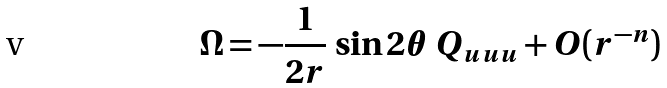<formula> <loc_0><loc_0><loc_500><loc_500>\Omega = - \frac { 1 } { 2 r } \, \sin { 2 \theta } \, Q _ { u u u } + O ( r ^ { - n } )</formula> 